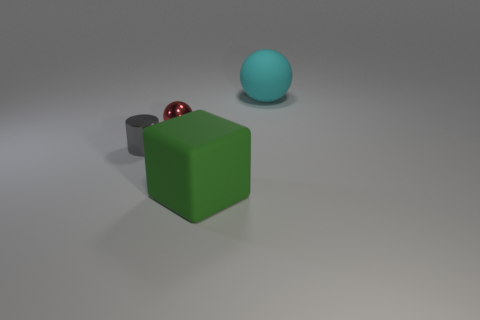There is a thing that is the same size as the matte sphere; what material is it?
Give a very brief answer. Rubber. What size is the object behind the tiny red shiny thing?
Give a very brief answer. Large. There is a matte object that is behind the big matte cube; is it the same size as the sphere that is on the left side of the cube?
Offer a terse response. No. What number of cylinders have the same material as the tiny sphere?
Provide a short and direct response. 1. The block is what color?
Make the answer very short. Green. There is a cylinder; are there any big spheres to the left of it?
Provide a short and direct response. No. Do the large block and the big matte ball have the same color?
Offer a very short reply. No. There is a red metal object in front of the ball right of the green matte cube; what size is it?
Your answer should be compact. Small. The gray metal object has what shape?
Keep it short and to the point. Cylinder. What is the big object left of the cyan rubber object made of?
Offer a terse response. Rubber. 